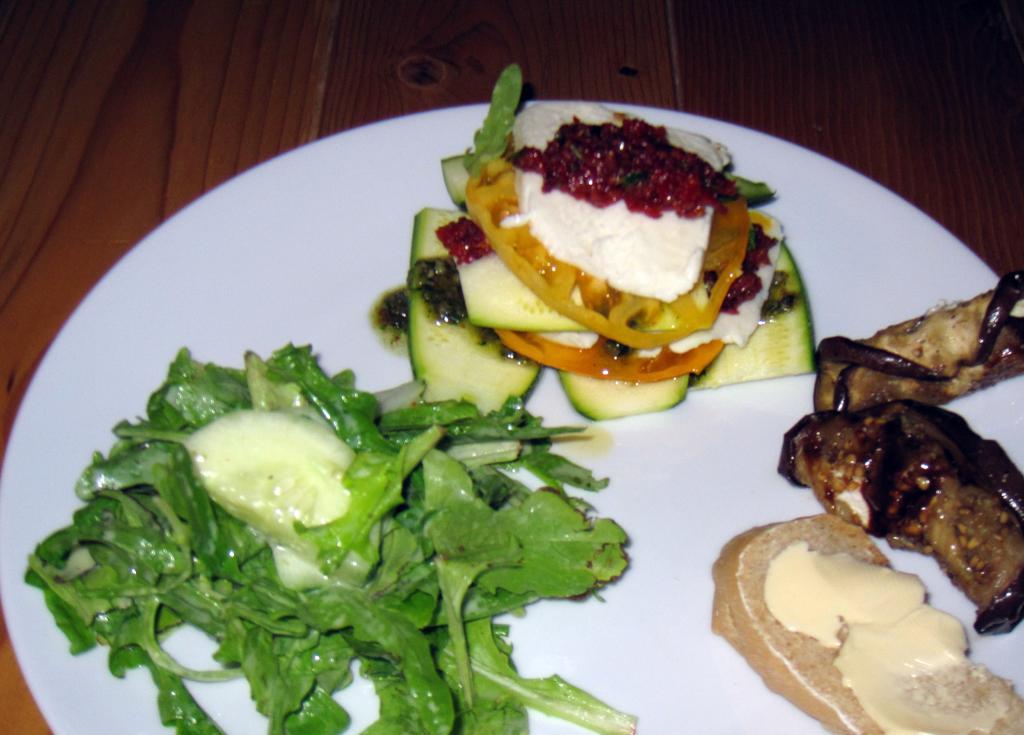In one or two sentences, can you explain what this image depicts? There are food items on a plate on a wooden surface. 